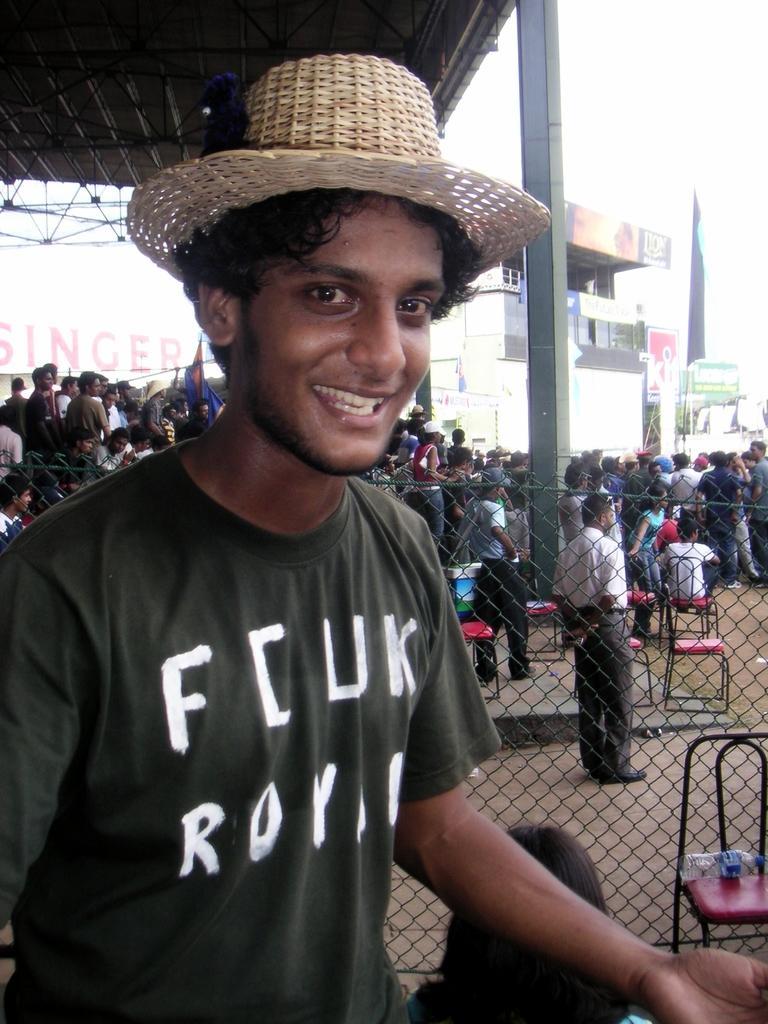Can you describe this image briefly? In this image we can see a man with a hat. In the background we can see many people standing. Image also consists of chairs, buildings, fence and also a water bottle. We can also see a roof for shelter. 